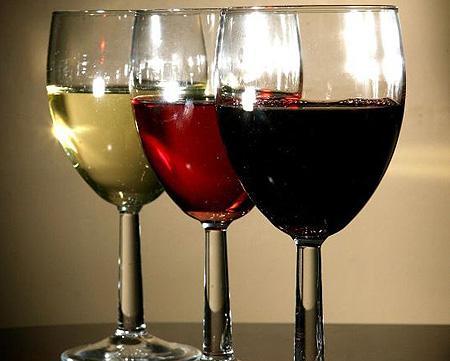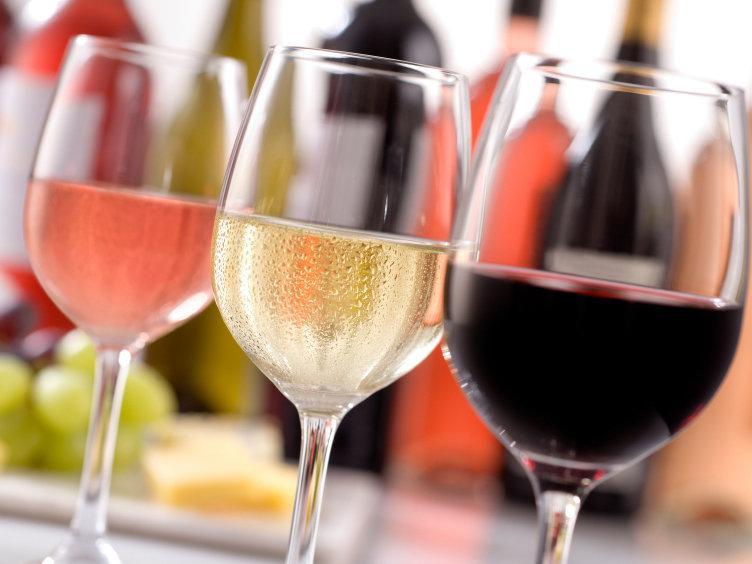The first image is the image on the left, the second image is the image on the right. For the images shown, is this caption "One of the images contains exactly two glasses of wine." true? Answer yes or no. No. 